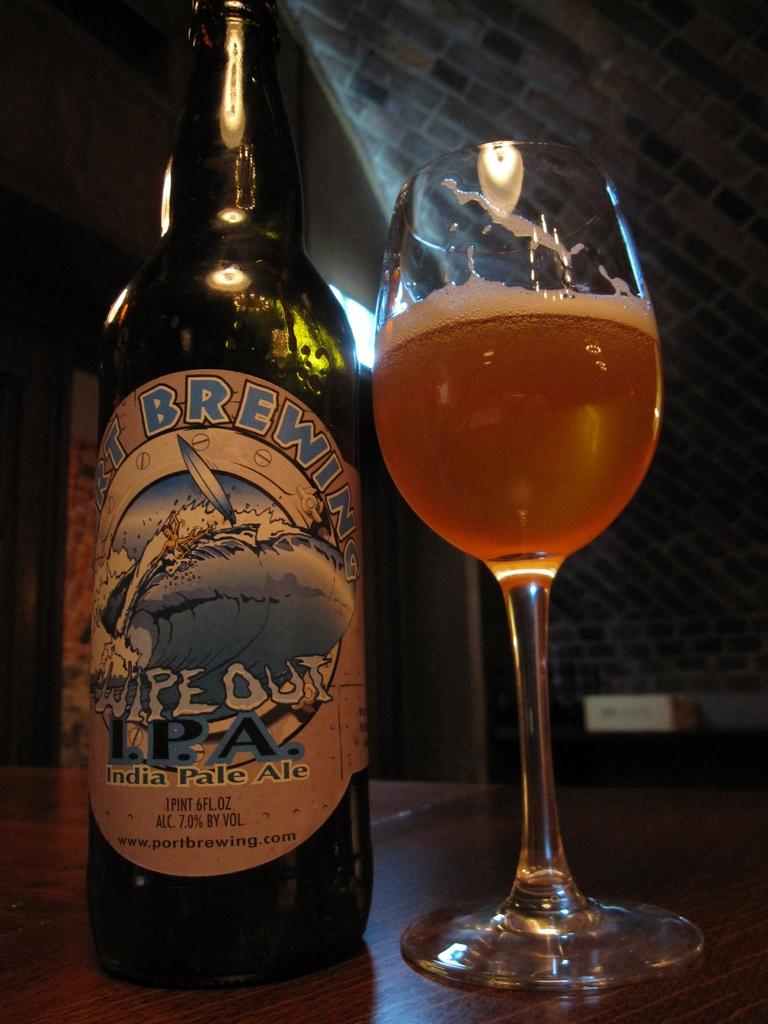What is the name of the beer?
Give a very brief answer. Wipe out. What is the brand of beer?
Offer a very short reply. Wipe out. 